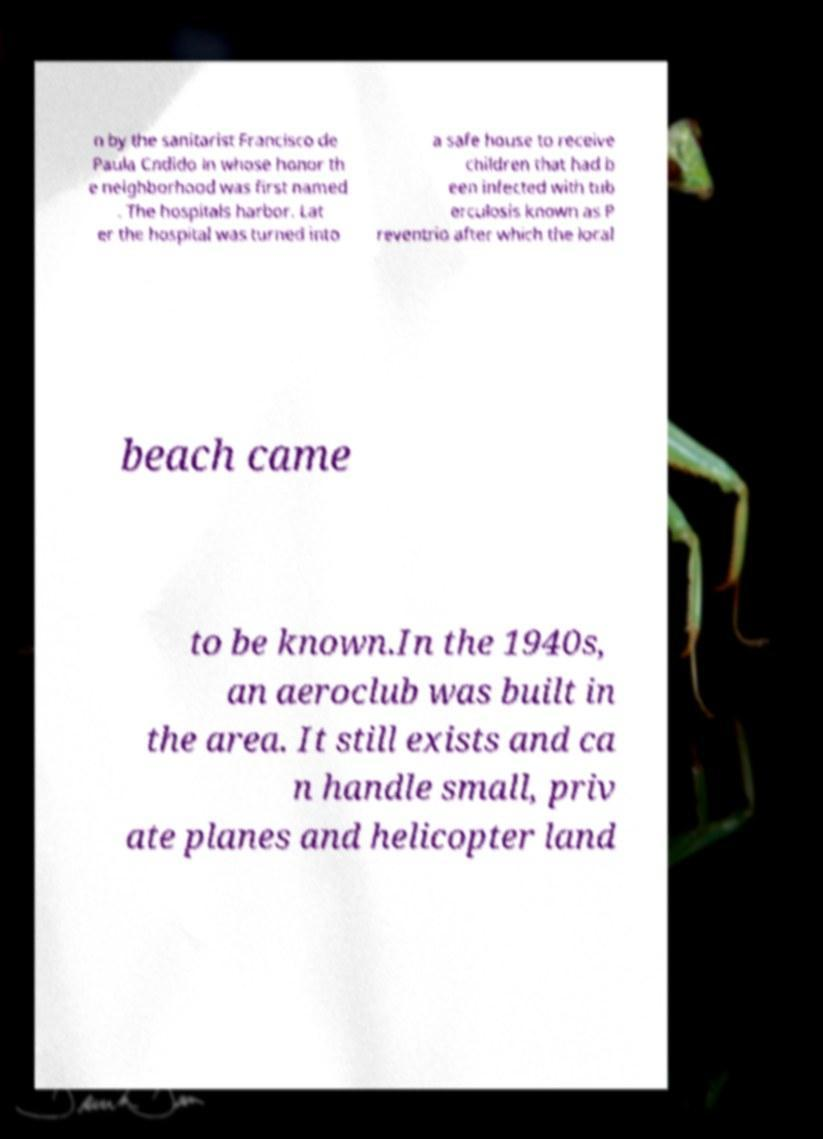Could you assist in decoding the text presented in this image and type it out clearly? n by the sanitarist Francisco de Paula Cndido in whose honor th e neighborhood was first named . The hospitals harbor. Lat er the hospital was turned into a safe house to receive children that had b een infected with tub erculosis known as P reventrio after which the local beach came to be known.In the 1940s, an aeroclub was built in the area. It still exists and ca n handle small, priv ate planes and helicopter land 